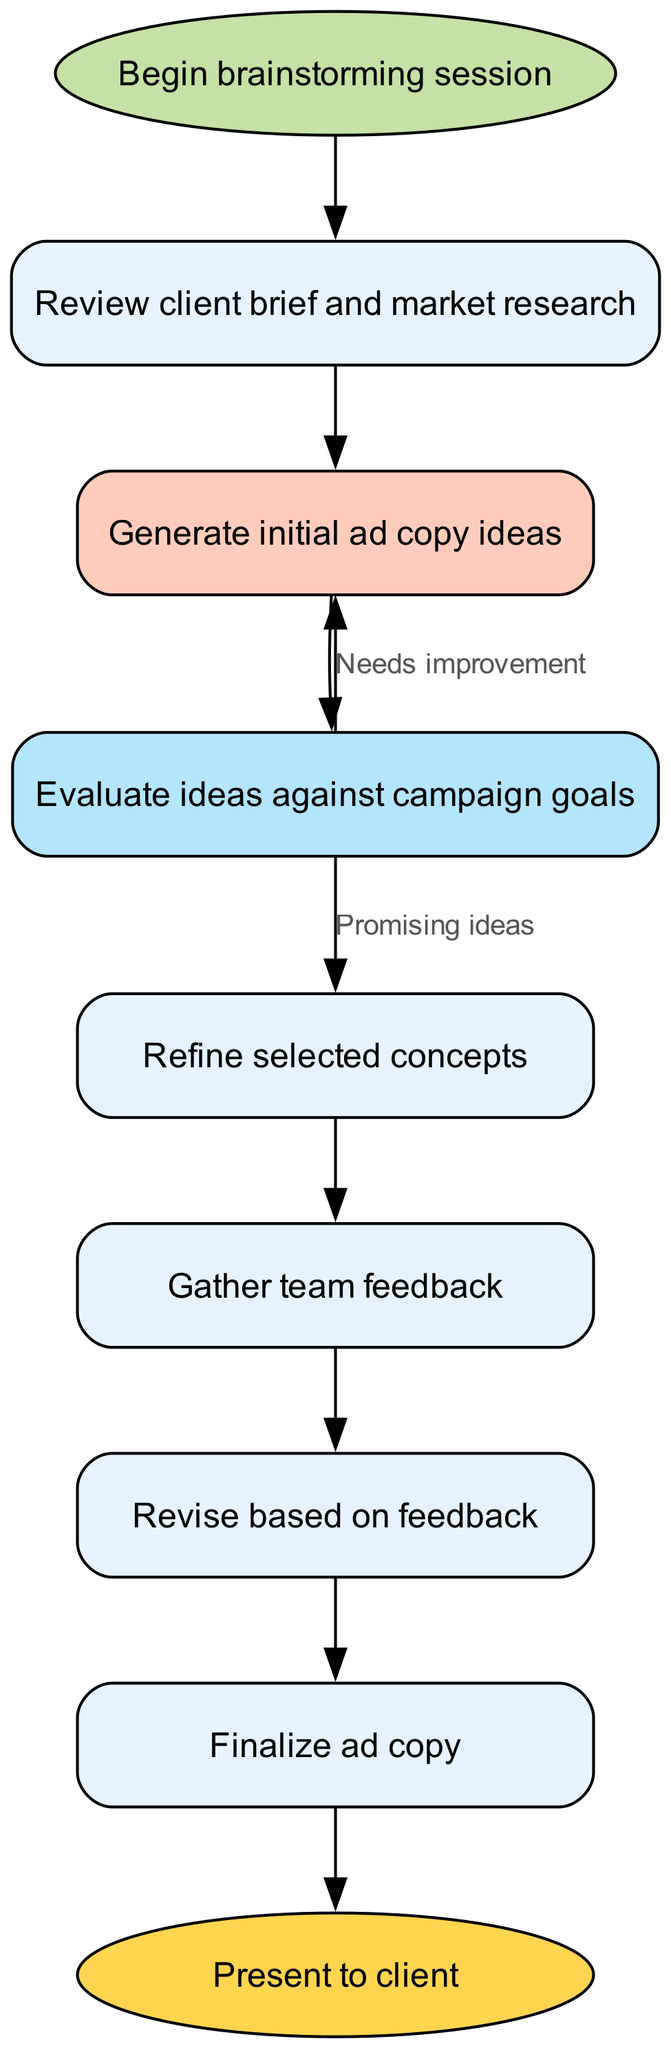What is the starting point of the process? The diagram indicates that the process begins with the node labeled 'Begin brainstorming session', which is the first step in the flow.
Answer: Begin brainstorming session How many nodes are in the flowchart? By counting each individual node represented in the diagram, there are a total of nine nodes that contribute to the overall flow of the ad copy brainstorming process.
Answer: 9 What is the outcome after refining ideas? The next step after refining the selected concepts is to gather team feedback, as indicated by the arrow leading from the 'Refine selected concepts' node to the 'Gather team feedback' node.
Answer: Gather team feedback What happens if ideas need improvement during the review step? The flowchart shows that if the ideas need improvement, the process loops back to the 'Generate initial ad copy ideas' node, highlighting the need to ideate further.
Answer: Needs improvement Which two important activities follow the feedback collection? After gathering feedback, the flowchart shows two subsequent nodes: 'Revise based on feedback' and 'Finalize ad copy', signifying the progression from feedback to refinement and finalization.
Answer: Revise based on feedback, Finalize ad copy What color represents the idea generation stage? In the flowchart, the idea generation stage is represented in orange, specifically in the node 'Generate initial ad copy ideas', which uses the fill color described in the diagram's specifications.
Answer: Orange What is the last step before presenting to the client? The step just before presenting to the client is 'Finalize ad copy', indicating that final adjustments are made prior to the client presentation.
Answer: Finalize ad copy Which step comes directly after evaluating ideas? Following the evaluation of ideas against campaign goals, the next step in the process is to refine the selected concepts, showing a progressive move from evaluation to refinement.
Answer: Refine selected concepts What is the shape of the starting node? In the diagram, the starting node, 'Begin brainstorming session', is distinctly shaped as an ellipse, which is a design choice to emphasize it as the starting point of the process.
Answer: Ellipse 